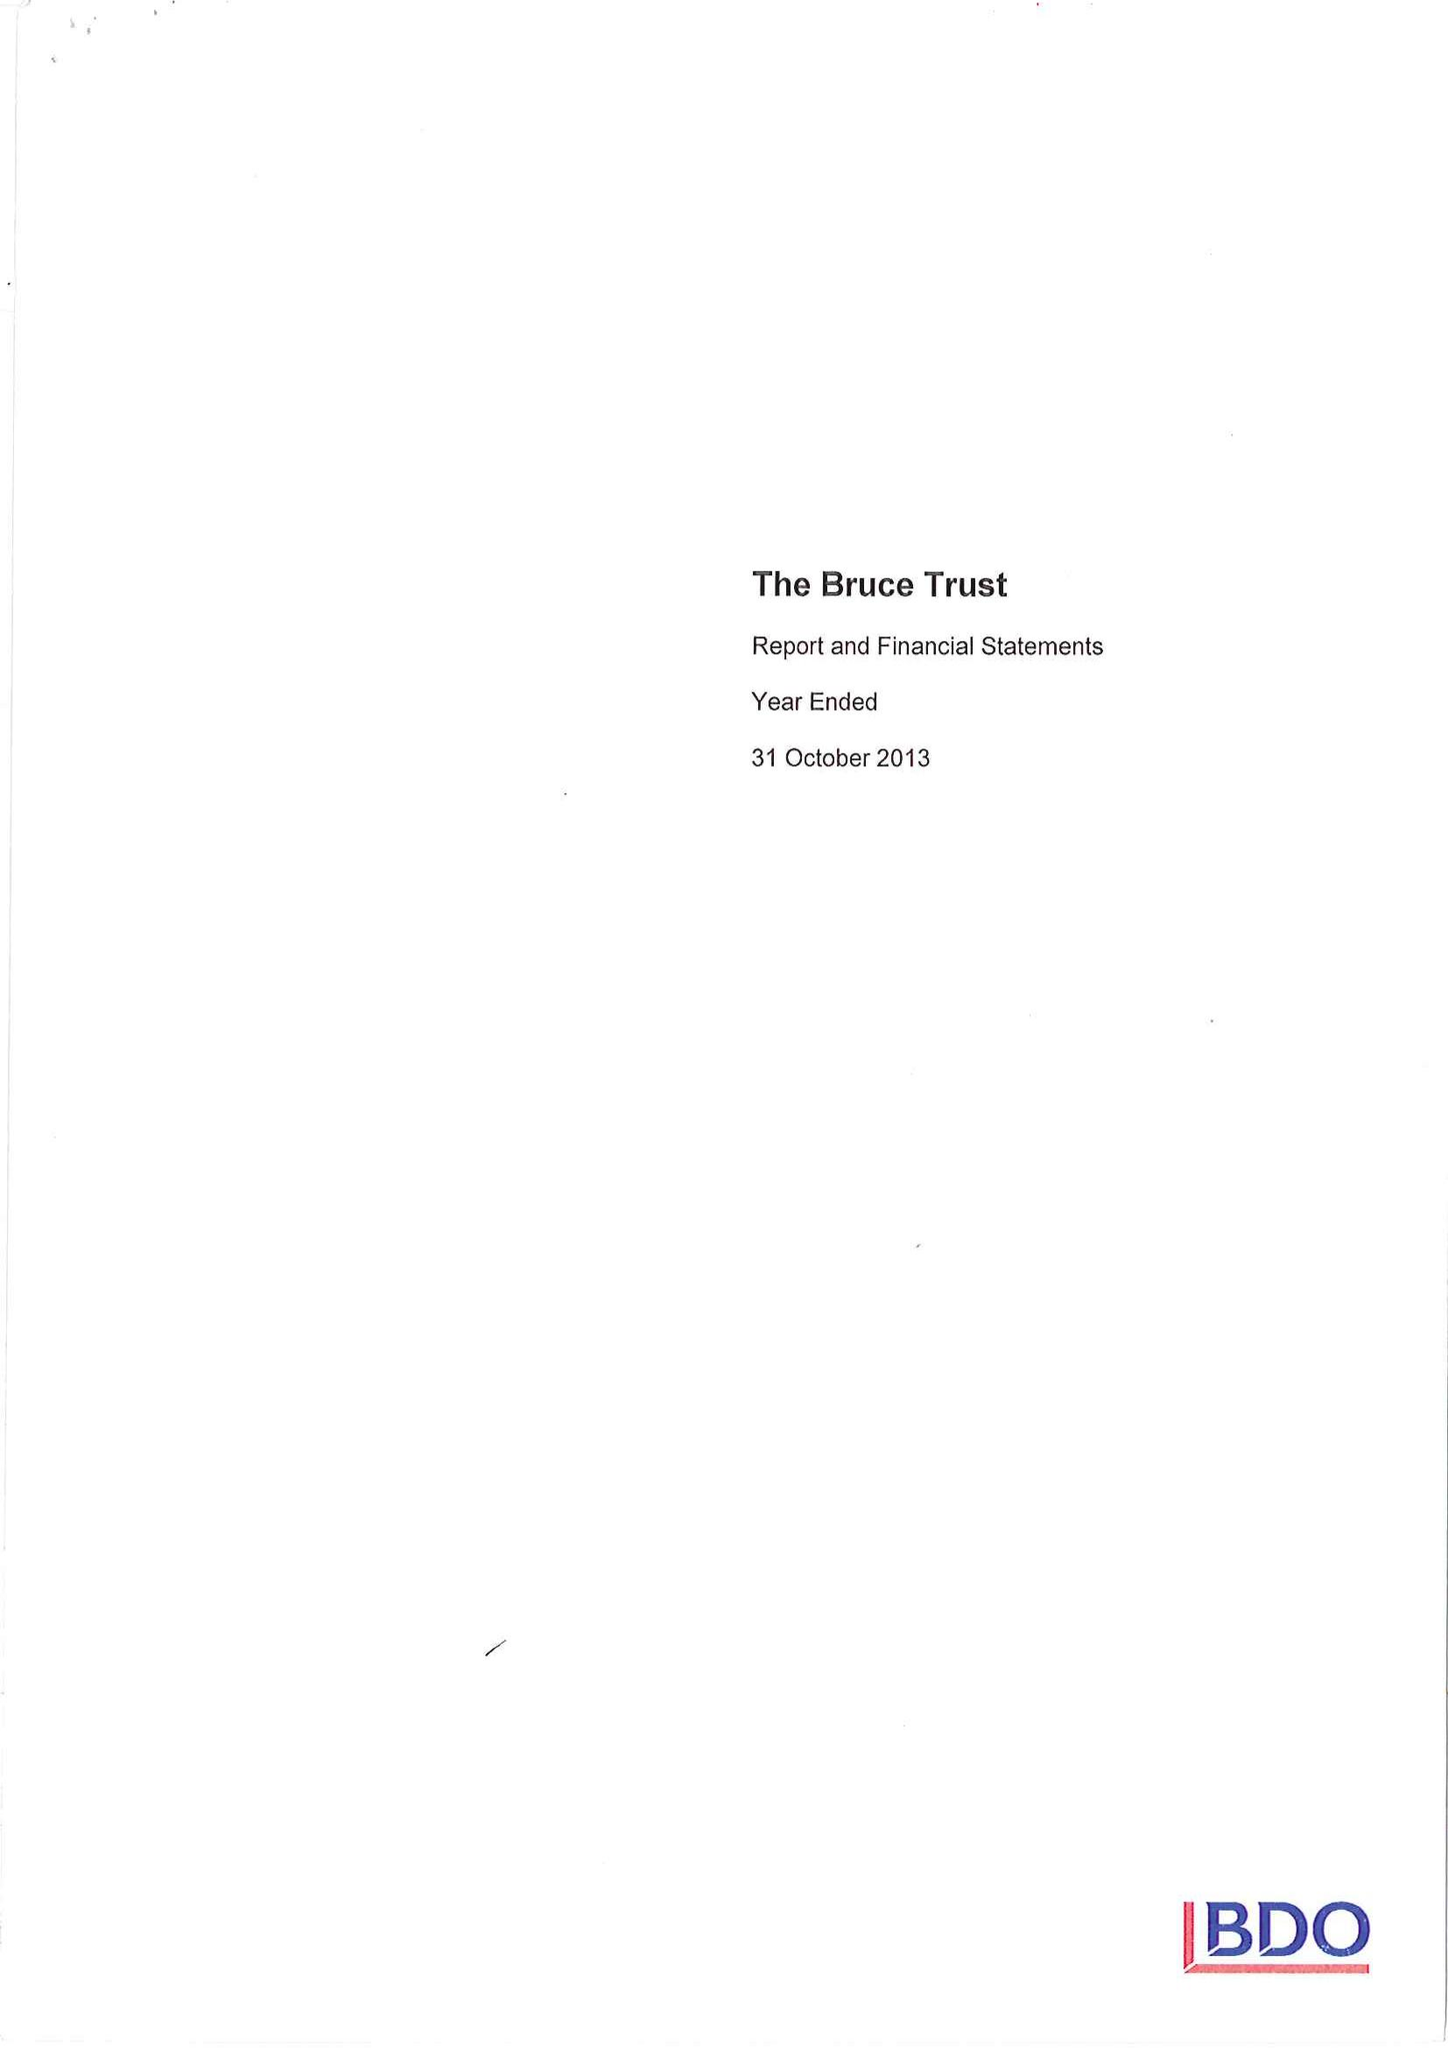What is the value for the spending_annually_in_british_pounds?
Answer the question using a single word or phrase. 132726.00 